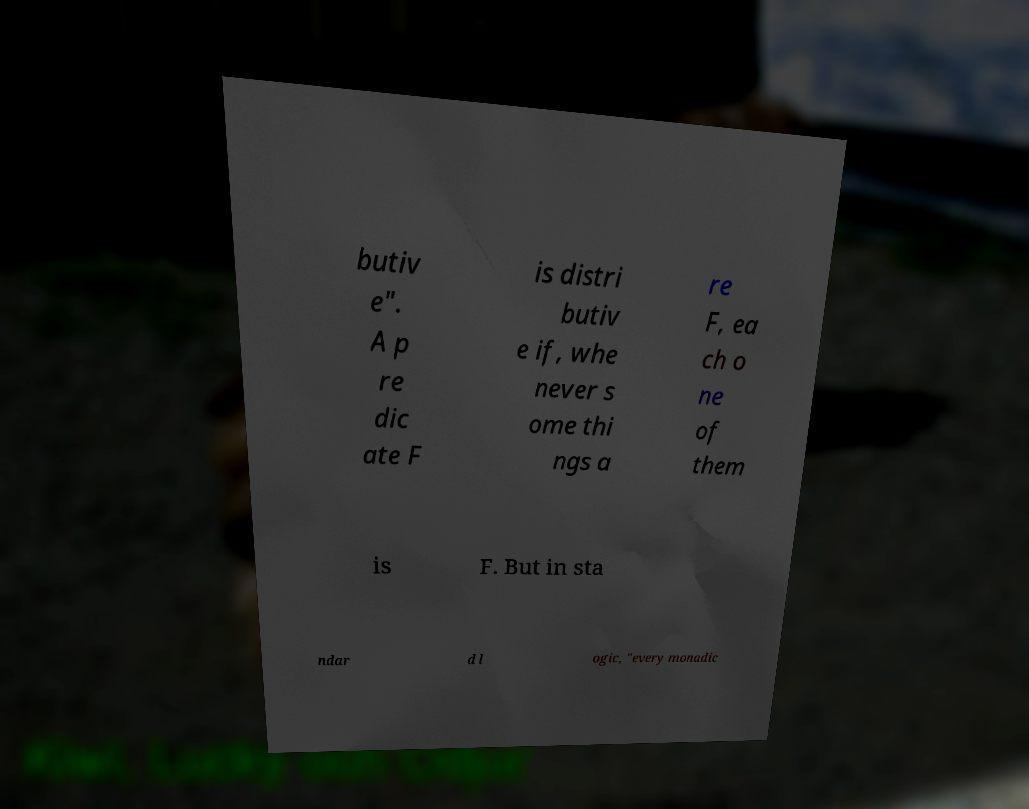Please identify and transcribe the text found in this image. butiv e". A p re dic ate F is distri butiv e if, whe never s ome thi ngs a re F, ea ch o ne of them is F. But in sta ndar d l ogic, "every monadic 